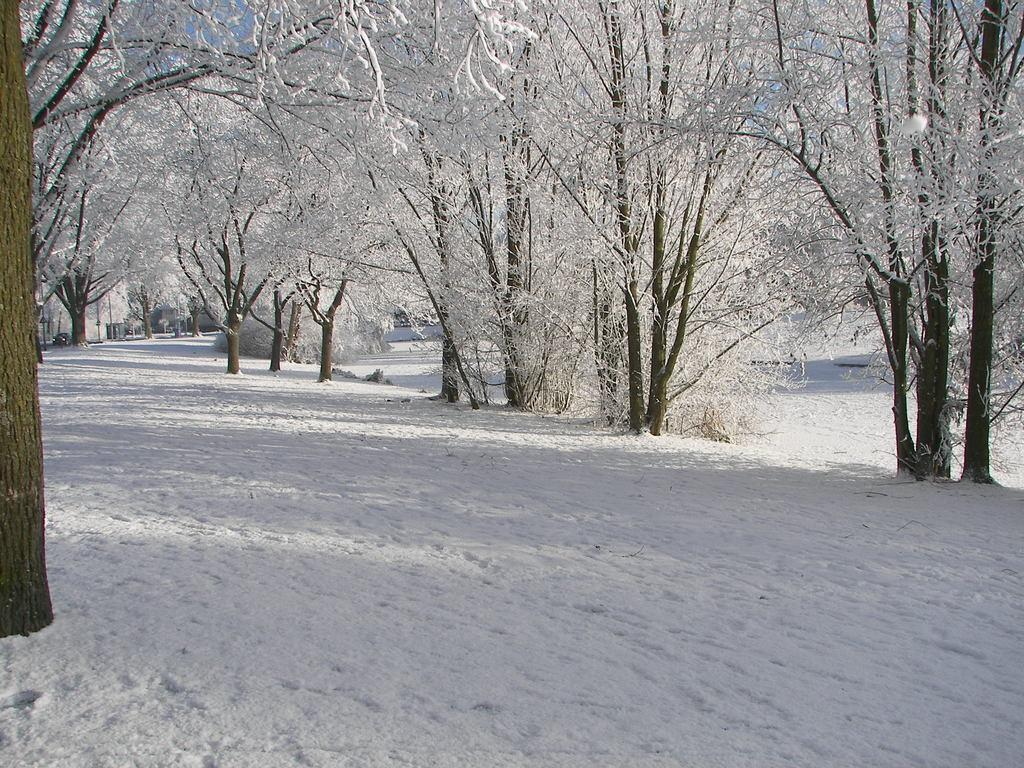What type of vegetation can be seen in the image? There are trees in the image. What is the weather like in the image? There is snow visible in the image, which suggests a cold or wintry environment. How does the actor grip the chain in the image? There is no actor or chain present in the image; it only features trees and snow. 